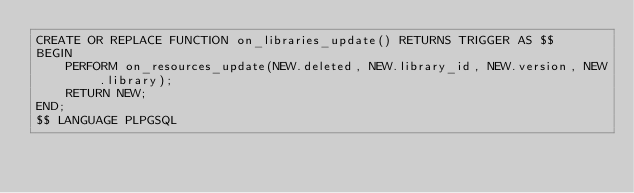<code> <loc_0><loc_0><loc_500><loc_500><_SQL_>CREATE OR REPLACE FUNCTION on_libraries_update() RETURNS TRIGGER AS $$
BEGIN
	PERFORM on_resources_update(NEW.deleted, NEW.library_id, NEW.version, NEW.library);
	RETURN NEW;
END;
$$ LANGUAGE PLPGSQL</code> 